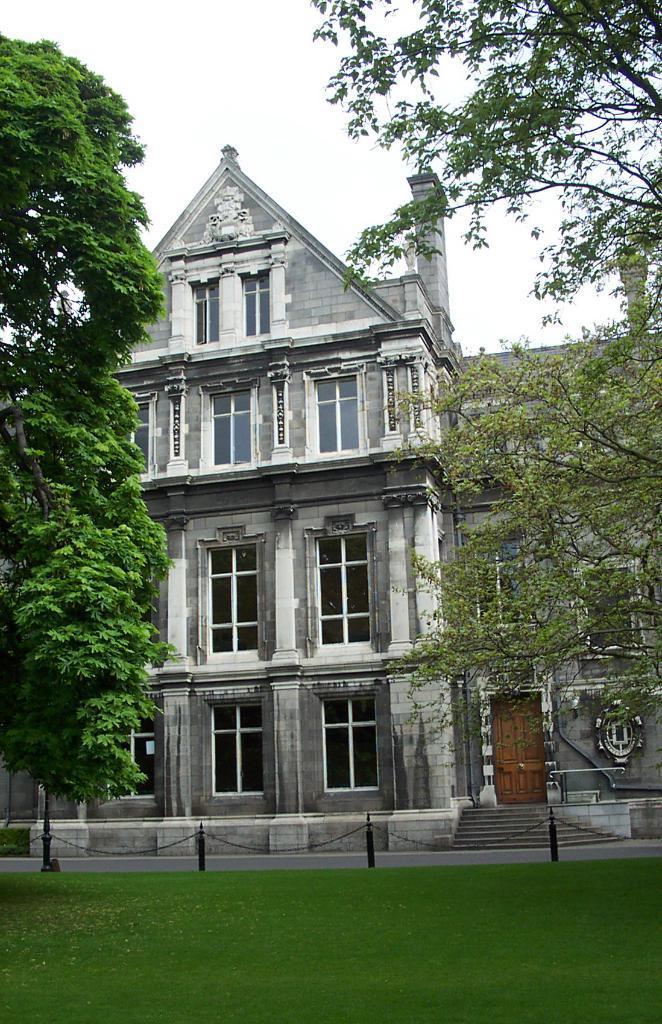Describe this image in one or two sentences. In the picture we can see a grass surface and behind it, we can see a path and near it, we can see house building with windows and beside it also we can see another building with door and window and besides the building we can see trees and behind the building we can see a sky. 